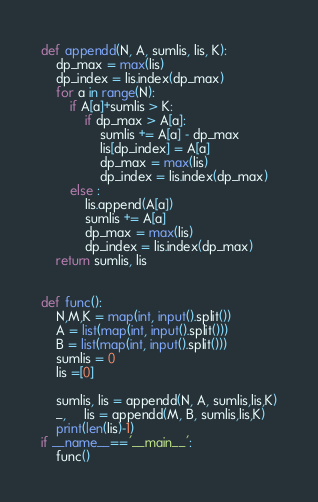Convert code to text. <code><loc_0><loc_0><loc_500><loc_500><_Python_>
def appendd(N, A, sumlis, lis, K):
    dp_max = max(lis)
    dp_index = lis.index(dp_max)
    for a in range(N):
        if A[a]+sumlis > K:
            if dp_max > A[a]:
                sumlis += A[a] - dp_max
                lis[dp_index] = A[a]
                dp_max = max(lis)
                dp_index = lis.index(dp_max)
        else :
            lis.append(A[a])
            sumlis += A[a]
            dp_max = max(lis)
            dp_index = lis.index(dp_max)
    return sumlis, lis


def func():
    N,M,K = map(int, input().split())
    A = list(map(int, input().split()))
    B = list(map(int, input().split()))
    sumlis = 0
    lis =[0]
    
    sumlis, lis = appendd(N, A, sumlis,lis,K)
    _,     lis = appendd(M, B, sumlis,lis,K)
    print(len(lis)-1)
if __name__=='__main__':
    func()
</code> 